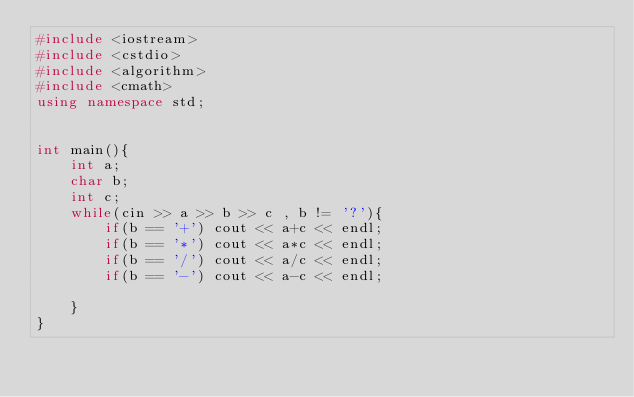<code> <loc_0><loc_0><loc_500><loc_500><_C++_>#include <iostream>
#include <cstdio>
#include <algorithm>
#include <cmath>
using namespace std;


int main(){
	int a;
	char b;
	int c;
	while(cin >> a >> b >> c , b != '?'){
		if(b == '+') cout << a+c << endl;
		if(b == '*') cout << a*c << endl;
		if(b == '/') cout << a/c << endl;
		if(b == '-') cout << a-c << endl;
		
	}
}</code> 